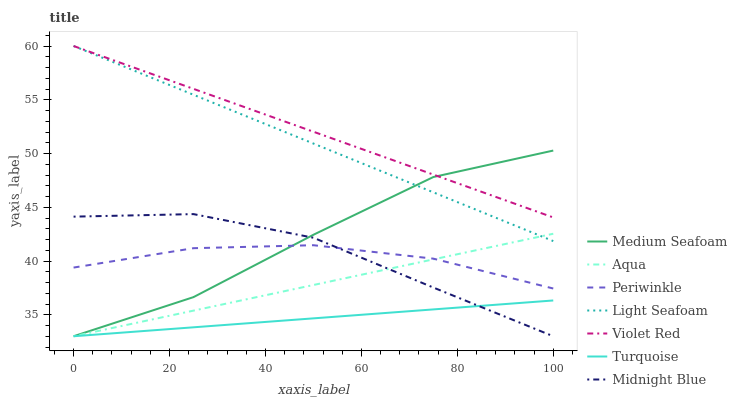Does Turquoise have the minimum area under the curve?
Answer yes or no. Yes. Does Violet Red have the maximum area under the curve?
Answer yes or no. Yes. Does Midnight Blue have the minimum area under the curve?
Answer yes or no. No. Does Midnight Blue have the maximum area under the curve?
Answer yes or no. No. Is Turquoise the smoothest?
Answer yes or no. Yes. Is Medium Seafoam the roughest?
Answer yes or no. Yes. Is Midnight Blue the smoothest?
Answer yes or no. No. Is Midnight Blue the roughest?
Answer yes or no. No. Does Midnight Blue have the lowest value?
Answer yes or no. Yes. Does Periwinkle have the lowest value?
Answer yes or no. No. Does Light Seafoam have the highest value?
Answer yes or no. Yes. Does Midnight Blue have the highest value?
Answer yes or no. No. Is Aqua less than Violet Red?
Answer yes or no. Yes. Is Violet Red greater than Turquoise?
Answer yes or no. Yes. Does Periwinkle intersect Medium Seafoam?
Answer yes or no. Yes. Is Periwinkle less than Medium Seafoam?
Answer yes or no. No. Is Periwinkle greater than Medium Seafoam?
Answer yes or no. No. Does Aqua intersect Violet Red?
Answer yes or no. No. 